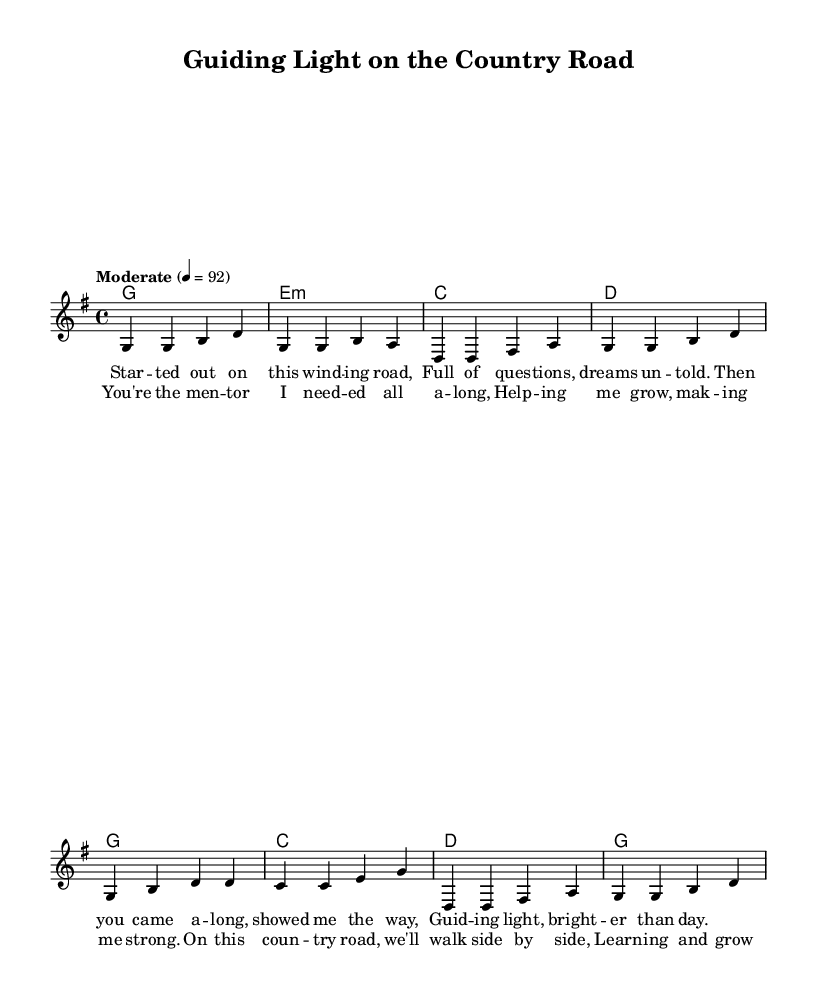What is the key signature of this music? The key signature is G major, which has one sharp (F#).
Answer: G major What is the time signature of this music? The time signature is shown at the beginning of the score as 4/4, indicating four beats per measure.
Answer: 4/4 What is the tempo marking for this piece? The tempo marking is indicated in the score with "Moderate" at a speed of 92 beats per minute.
Answer: Moderate 4 = 92 How many measures are in the verse? The verse consists of four measures as counted in the melody section before the chorus starts.
Answer: Four What chords are used in the chorus? The chords in the chorus are G, C, D, and G, as indicated in the harmonies section.
Answer: G, C, D, G What theme is presented in the lyrics of this song? The lyrics convey a theme of mentorship and personal growth, emphasizing guidance on life's journey.
Answer: Mentorship and personal growth How does the melodic structure of this piece reflect typical characteristics of country music? The melodic structure features simple, singable phrases and a narrative style in the lyrics, which are characteristic of country music's storytelling approach.
Answer: Simple, singable phrases 